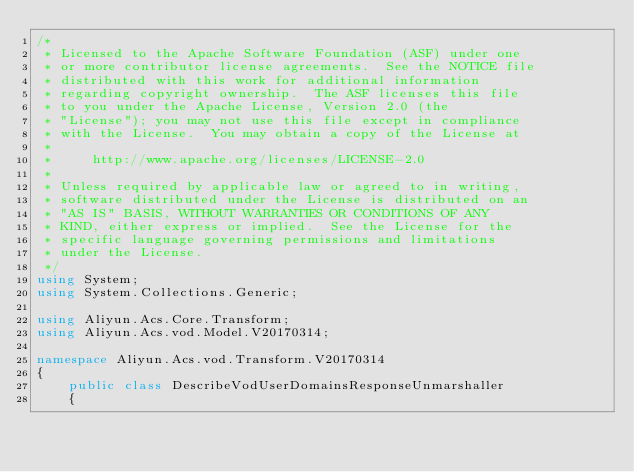<code> <loc_0><loc_0><loc_500><loc_500><_C#_>/*
 * Licensed to the Apache Software Foundation (ASF) under one
 * or more contributor license agreements.  See the NOTICE file
 * distributed with this work for additional information
 * regarding copyright ownership.  The ASF licenses this file
 * to you under the Apache License, Version 2.0 (the
 * "License"); you may not use this file except in compliance
 * with the License.  You may obtain a copy of the License at
 *
 *     http://www.apache.org/licenses/LICENSE-2.0
 *
 * Unless required by applicable law or agreed to in writing,
 * software distributed under the License is distributed on an
 * "AS IS" BASIS, WITHOUT WARRANTIES OR CONDITIONS OF ANY
 * KIND, either express or implied.  See the License for the
 * specific language governing permissions and limitations
 * under the License.
 */
using System;
using System.Collections.Generic;

using Aliyun.Acs.Core.Transform;
using Aliyun.Acs.vod.Model.V20170314;

namespace Aliyun.Acs.vod.Transform.V20170314
{
    public class DescribeVodUserDomainsResponseUnmarshaller
    {</code> 